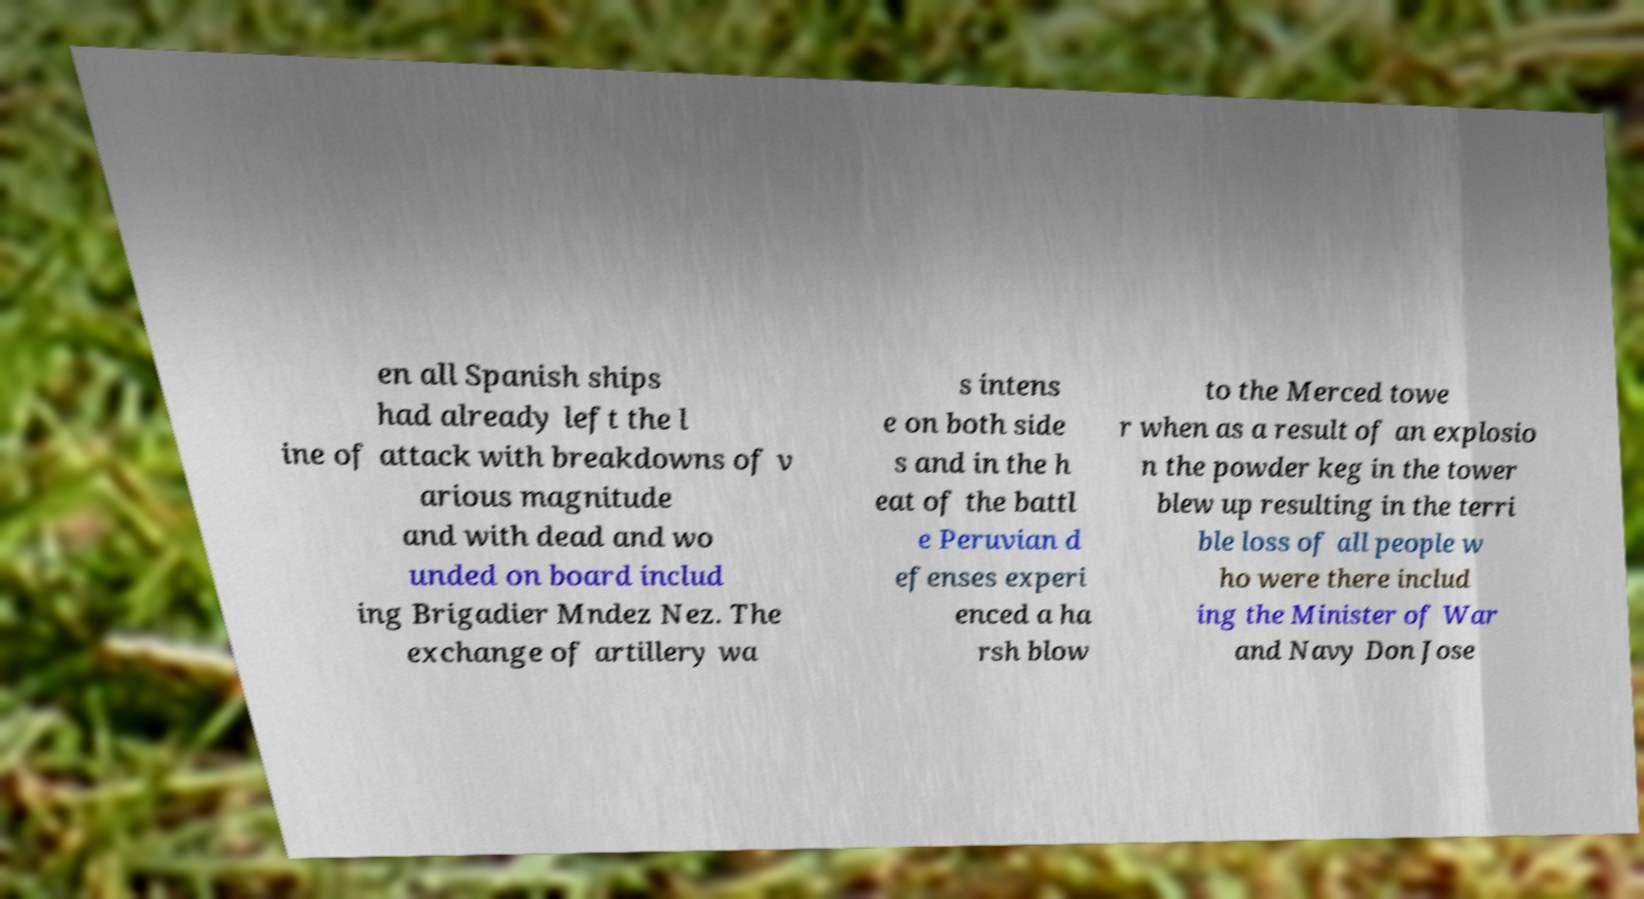For documentation purposes, I need the text within this image transcribed. Could you provide that? en all Spanish ships had already left the l ine of attack with breakdowns of v arious magnitude and with dead and wo unded on board includ ing Brigadier Mndez Nez. The exchange of artillery wa s intens e on both side s and in the h eat of the battl e Peruvian d efenses experi enced a ha rsh blow to the Merced towe r when as a result of an explosio n the powder keg in the tower blew up resulting in the terri ble loss of all people w ho were there includ ing the Minister of War and Navy Don Jose 